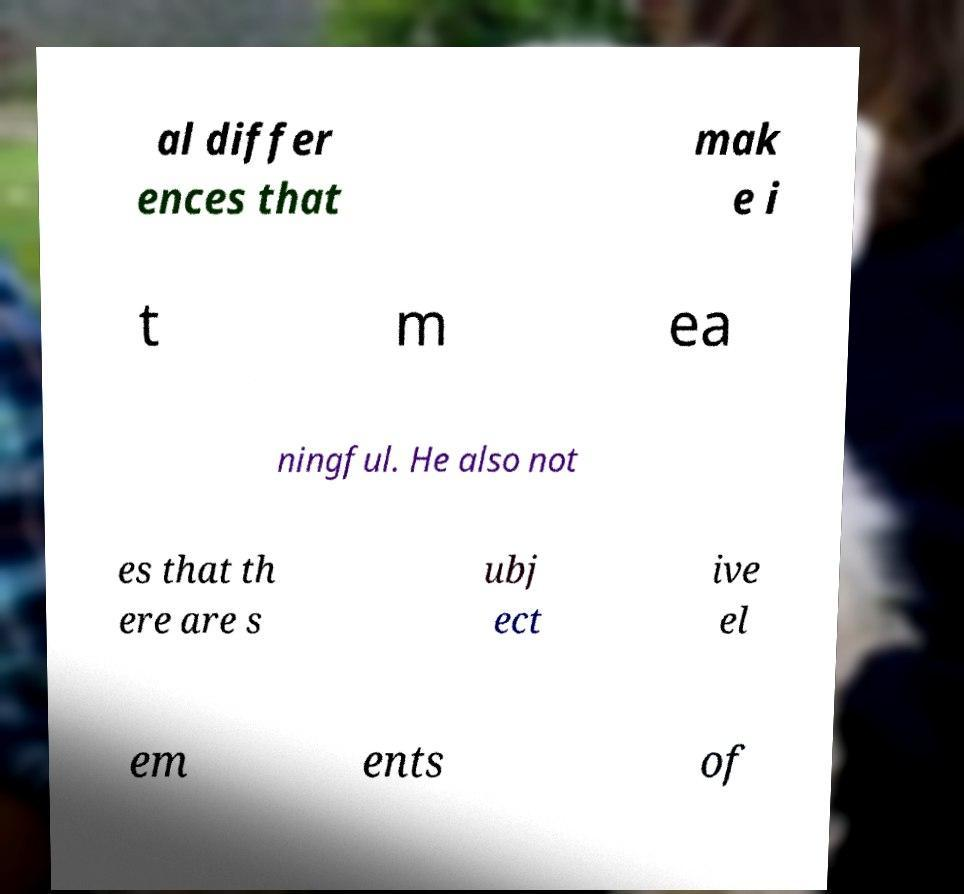Please identify and transcribe the text found in this image. al differ ences that mak e i t m ea ningful. He also not es that th ere are s ubj ect ive el em ents of 